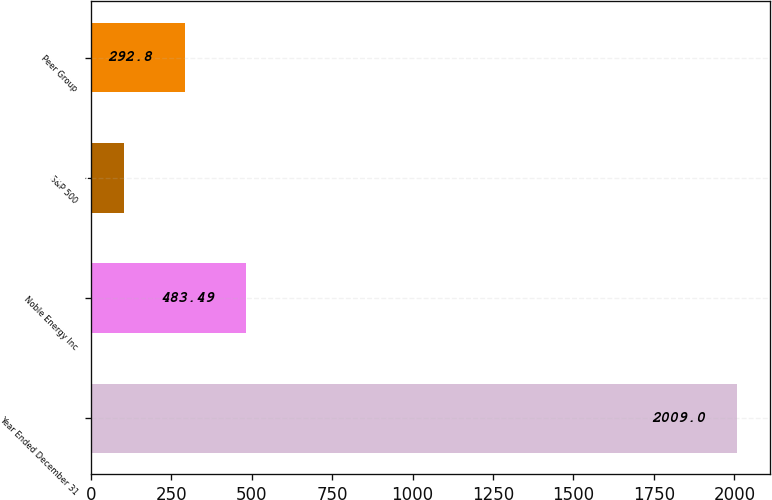<chart> <loc_0><loc_0><loc_500><loc_500><bar_chart><fcel>Year Ended December 31<fcel>Noble Energy Inc<fcel>S&P 500<fcel>Peer Group<nl><fcel>2009<fcel>483.49<fcel>102.11<fcel>292.8<nl></chart> 